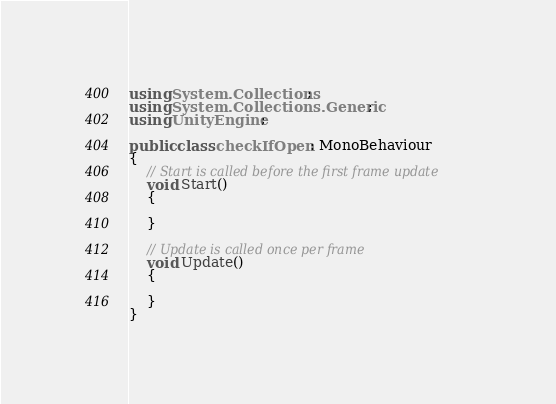<code> <loc_0><loc_0><loc_500><loc_500><_C#_>using System.Collections;
using System.Collections.Generic;
using UnityEngine;

public class checkIfOpen : MonoBehaviour
{
    // Start is called before the first frame update
    void Start()
    {
        
    }

    // Update is called once per frame
    void Update()
    {
        
    }
}
</code> 